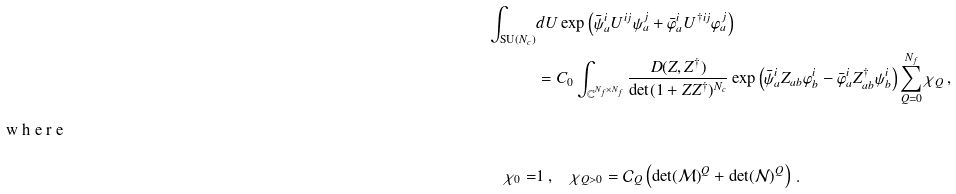<formula> <loc_0><loc_0><loc_500><loc_500>\int _ { \text {SU} ( N _ { c } ) } & d U \exp \left ( \bar { \psi } _ { a } ^ { i } U ^ { i j } \psi _ { a } ^ { j } + \bar { \varphi } _ { a } ^ { i } U ^ { \dagger i j } \varphi _ { a } ^ { j } \right ) \\ & = C _ { 0 } \int _ { \mathbb { C } ^ { N _ { f } \times N _ { f } } } \frac { D ( Z , Z ^ { \dag } ) } { \det ( 1 + Z Z ^ { \dag } ) ^ { N _ { c } } } \exp \left ( \bar { \psi } _ { a } ^ { i } Z _ { a b } \varphi _ { b } ^ { i } - \bar { \varphi } _ { a } ^ { i } Z _ { a b } ^ { \dag } \psi _ { b } ^ { i } \right ) \sum _ { Q = 0 } ^ { N _ { f } } \chi _ { Q } \, , \intertext { w h e r e } \chi _ { 0 } = & 1 \, , \quad \chi _ { Q > 0 } = \mathcal { C } _ { Q } \left ( \det ( \mathcal { M } ) ^ { Q } + \det ( \mathcal { N } ) ^ { Q } \right ) \, .</formula> 